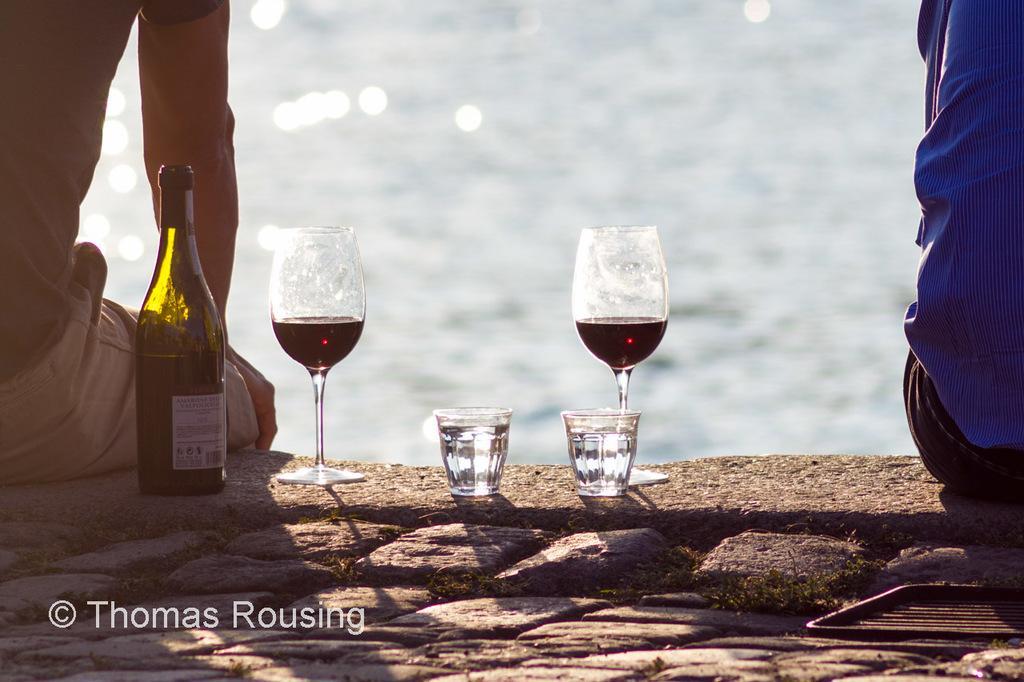In one or two sentences, can you explain what this image depicts? In this picture there is a wine bottle and wine glasses placed on the floor. There are two persons sitting. In the background there is a water. 